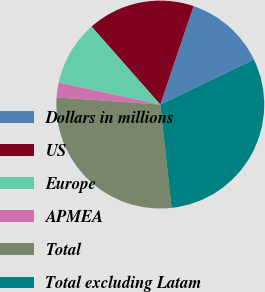Convert chart. <chart><loc_0><loc_0><loc_500><loc_500><pie_chart><fcel>Dollars in millions<fcel>US<fcel>Europe<fcel>APMEA<fcel>Total<fcel>Total excluding Latam<nl><fcel>12.67%<fcel>16.69%<fcel>10.11%<fcel>2.29%<fcel>27.84%<fcel>30.4%<nl></chart> 